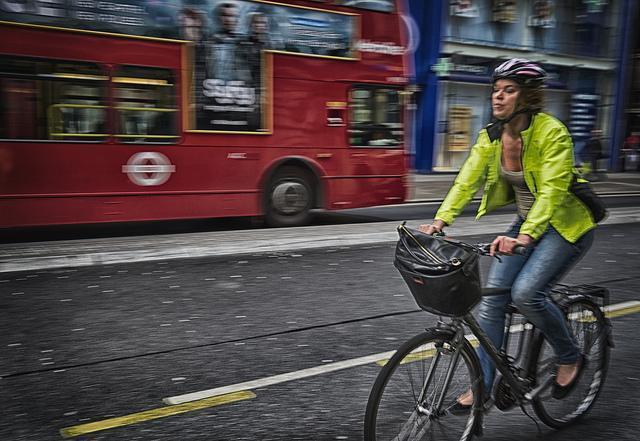How many giraffes are there?
Give a very brief answer. 0. 